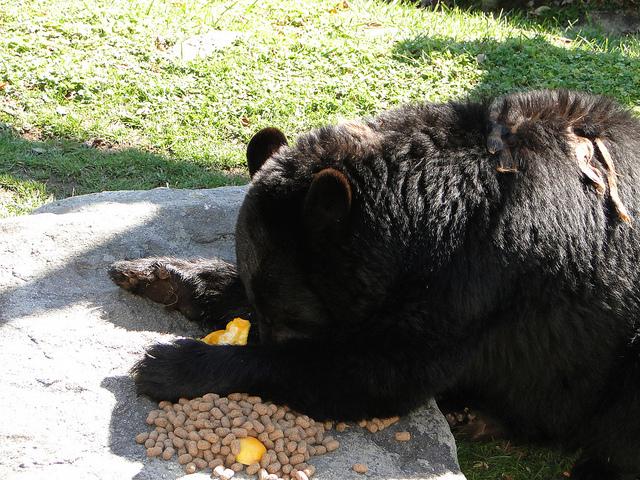What color is the bear?
Give a very brief answer. Black. What is the bear eating?
Quick response, please. Peanuts. What is this animal?
Write a very short answer. Bear. What are the bears looking for?
Concise answer only. Food. What color is this animal?
Be succinct. Brown. Is the bear swimming or standing?
Keep it brief. Laying. Are the bears swimming?
Give a very brief answer. No. Is the bear eating peanuts?
Write a very short answer. Yes. What is the bear doing?
Concise answer only. Eating. What are the animals looking at?
Answer briefly. Food. 